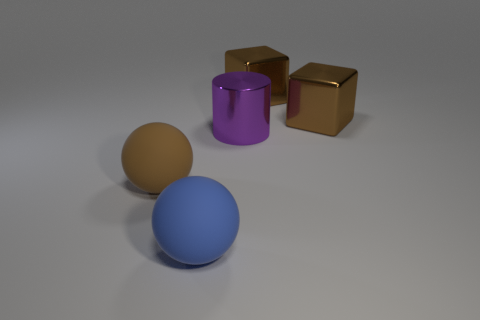There is a brown object that is to the left of the blue sphere; is its size the same as the blue rubber ball?
Make the answer very short. Yes. What number of other things are there of the same shape as the large blue matte thing?
Provide a succinct answer. 1. How many green objects are big rubber spheres or large objects?
Your answer should be very brief. 0. What is the color of the large object that is both behind the blue rubber sphere and in front of the purple shiny object?
Give a very brief answer. Brown. Are there an equal number of metal cylinders in front of the brown sphere and blue things?
Keep it short and to the point. No. What number of small brown things are there?
Offer a very short reply. 0. The big thing that is behind the blue matte object and on the left side of the metallic cylinder has what shape?
Ensure brevity in your answer.  Sphere. Is there another big ball made of the same material as the large blue sphere?
Offer a very short reply. Yes. Is the number of big blue rubber objects that are to the left of the blue sphere the same as the number of cylinders that are to the right of the big brown sphere?
Make the answer very short. No. There is a brown object that is in front of the purple metallic cylinder; what is its size?
Your answer should be compact. Large. 